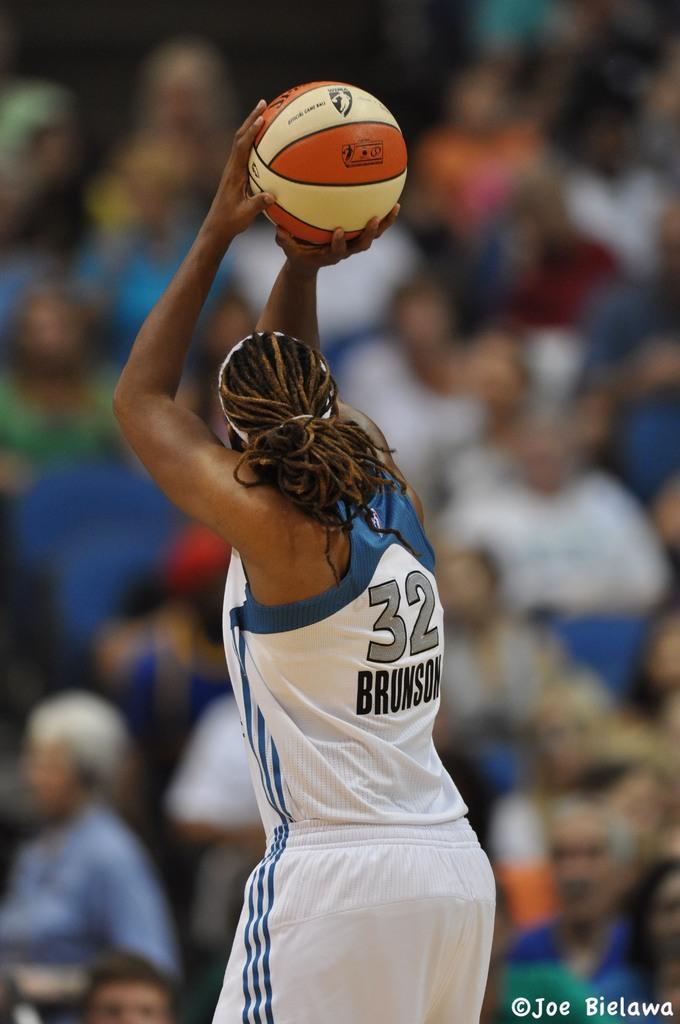Who is the main subject in the image? There is a person in the image. What is the person holding in his hand? The person is holding a basketball in his hand. Are there any other people visible in the image? Yes, there are a few people in front of the person holding the basketball. What type of feast is being prepared by the person in the image? There is no indication of a feast or any food preparation in the image; the person is holding a basketball. 